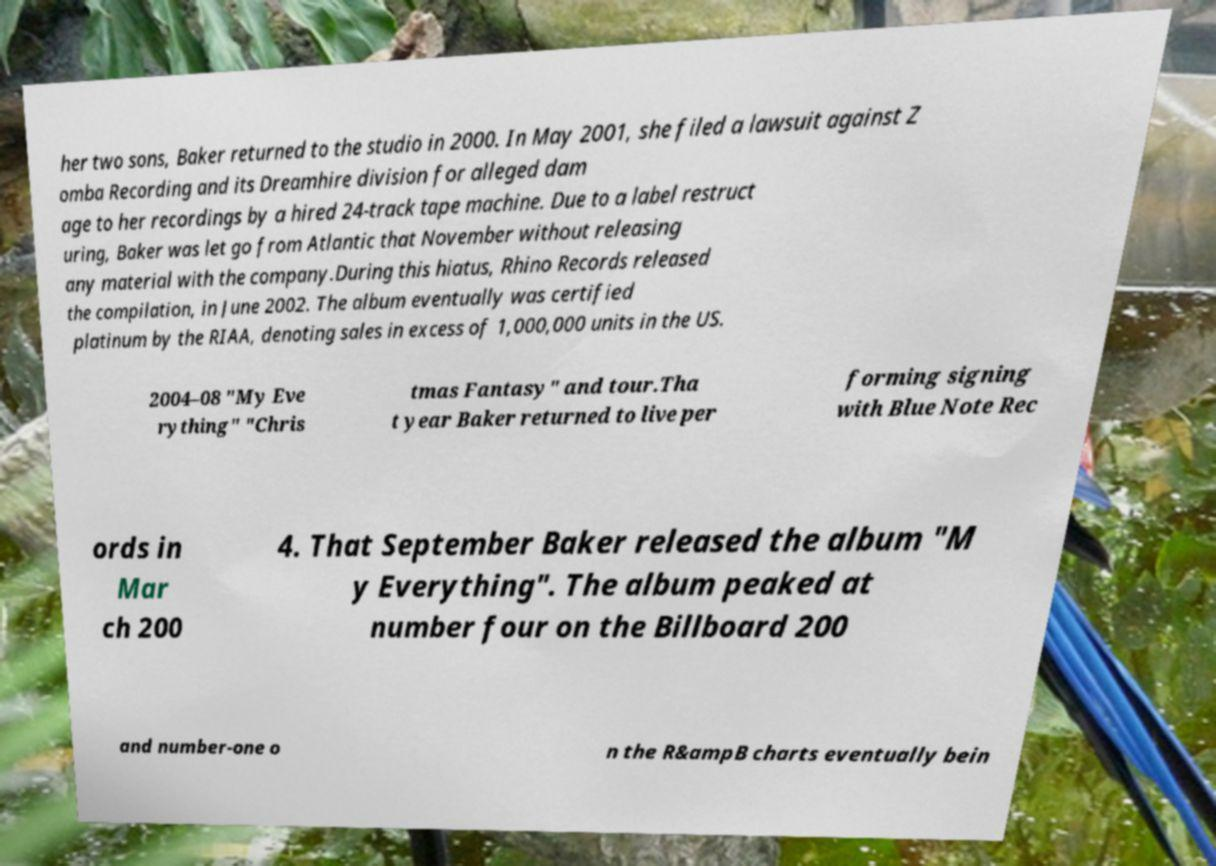For documentation purposes, I need the text within this image transcribed. Could you provide that? her two sons, Baker returned to the studio in 2000. In May 2001, she filed a lawsuit against Z omba Recording and its Dreamhire division for alleged dam age to her recordings by a hired 24-track tape machine. Due to a label restruct uring, Baker was let go from Atlantic that November without releasing any material with the company.During this hiatus, Rhino Records released the compilation, in June 2002. The album eventually was certified platinum by the RIAA, denoting sales in excess of 1,000,000 units in the US. 2004–08 "My Eve rything" "Chris tmas Fantasy" and tour.Tha t year Baker returned to live per forming signing with Blue Note Rec ords in Mar ch 200 4. That September Baker released the album "M y Everything". The album peaked at number four on the Billboard 200 and number-one o n the R&ampB charts eventually bein 